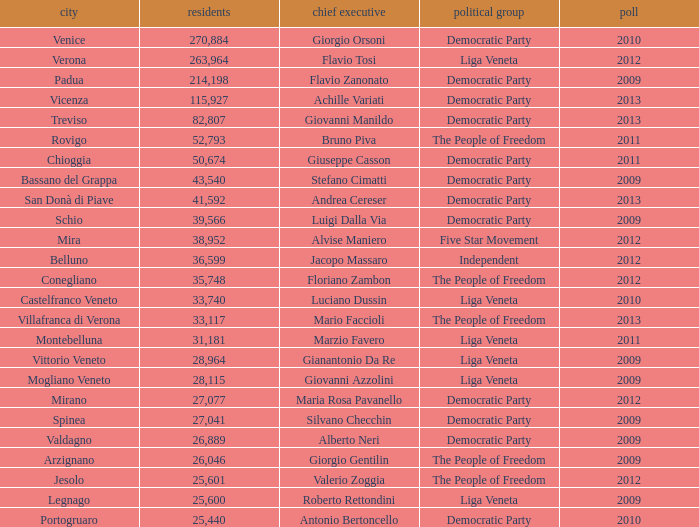What party was achille variati afilliated with? Democratic Party. 